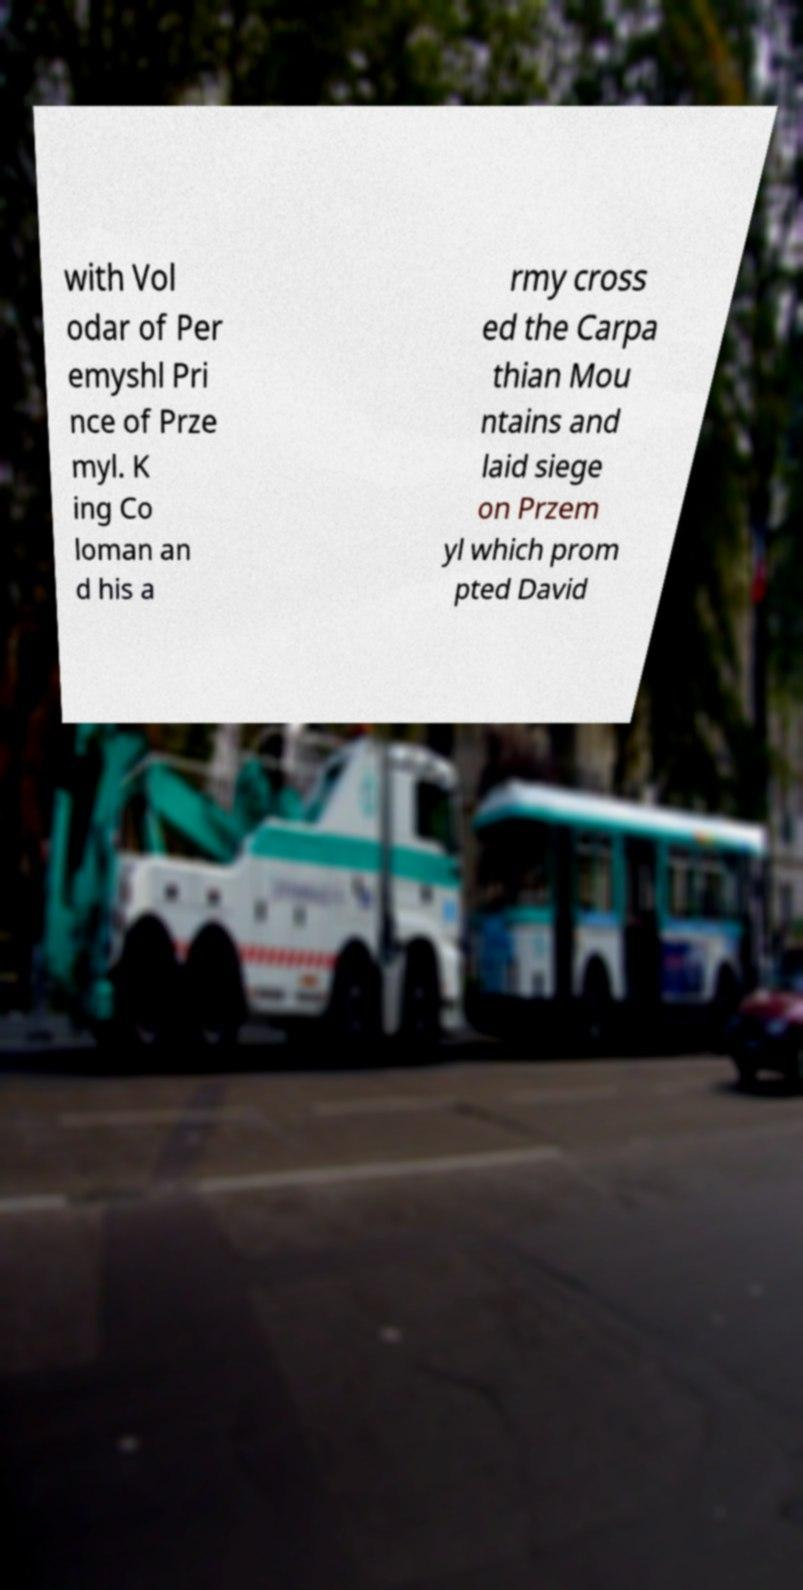Could you assist in decoding the text presented in this image and type it out clearly? with Vol odar of Per emyshl Pri nce of Prze myl. K ing Co loman an d his a rmy cross ed the Carpa thian Mou ntains and laid siege on Przem yl which prom pted David 